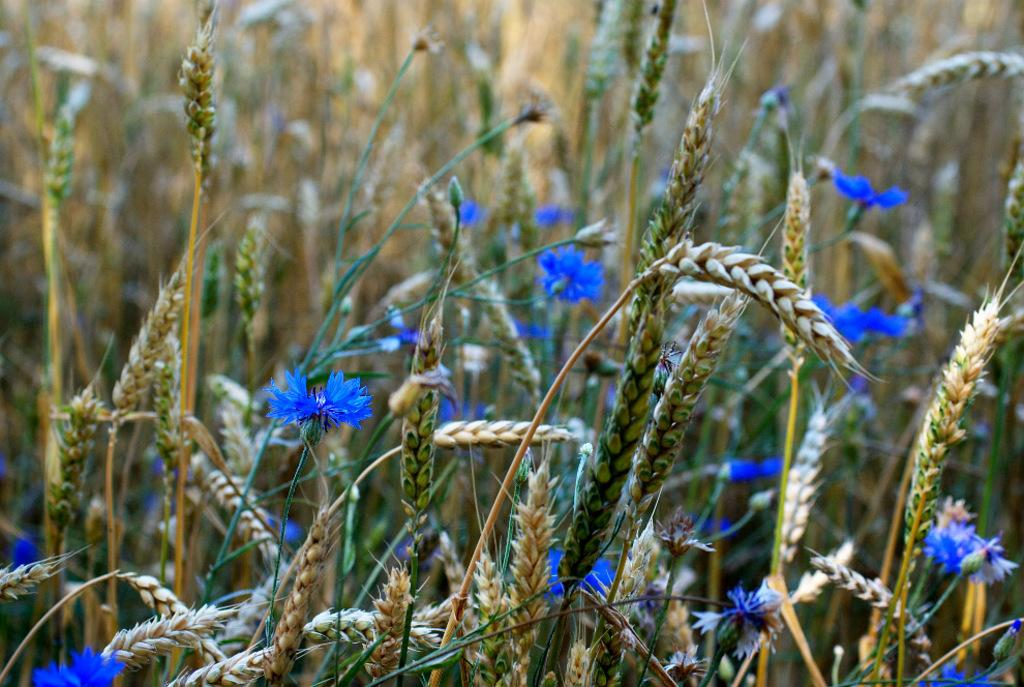What type of vegetation is present in the image? There is grass with flowers in the image. What else can be seen in the image besides the vegetation? There are grains in the image. Can you describe the background of the image? The background of the image is blurred. What type of amusement can be seen in the image? There is no amusement present in the image; it features grass with flowers and grains. What kind of agreement is being made in the image? There is no agreement being made in the image; it is a still image of grass with flowers and grains. 